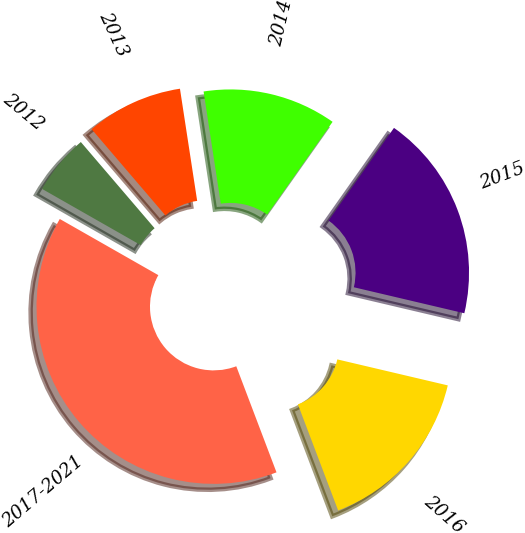Convert chart to OTSL. <chart><loc_0><loc_0><loc_500><loc_500><pie_chart><fcel>2012<fcel>2013<fcel>2014<fcel>2015<fcel>2016<fcel>2017-2021<nl><fcel>5.49%<fcel>8.84%<fcel>12.2%<fcel>18.9%<fcel>15.55%<fcel>39.01%<nl></chart> 